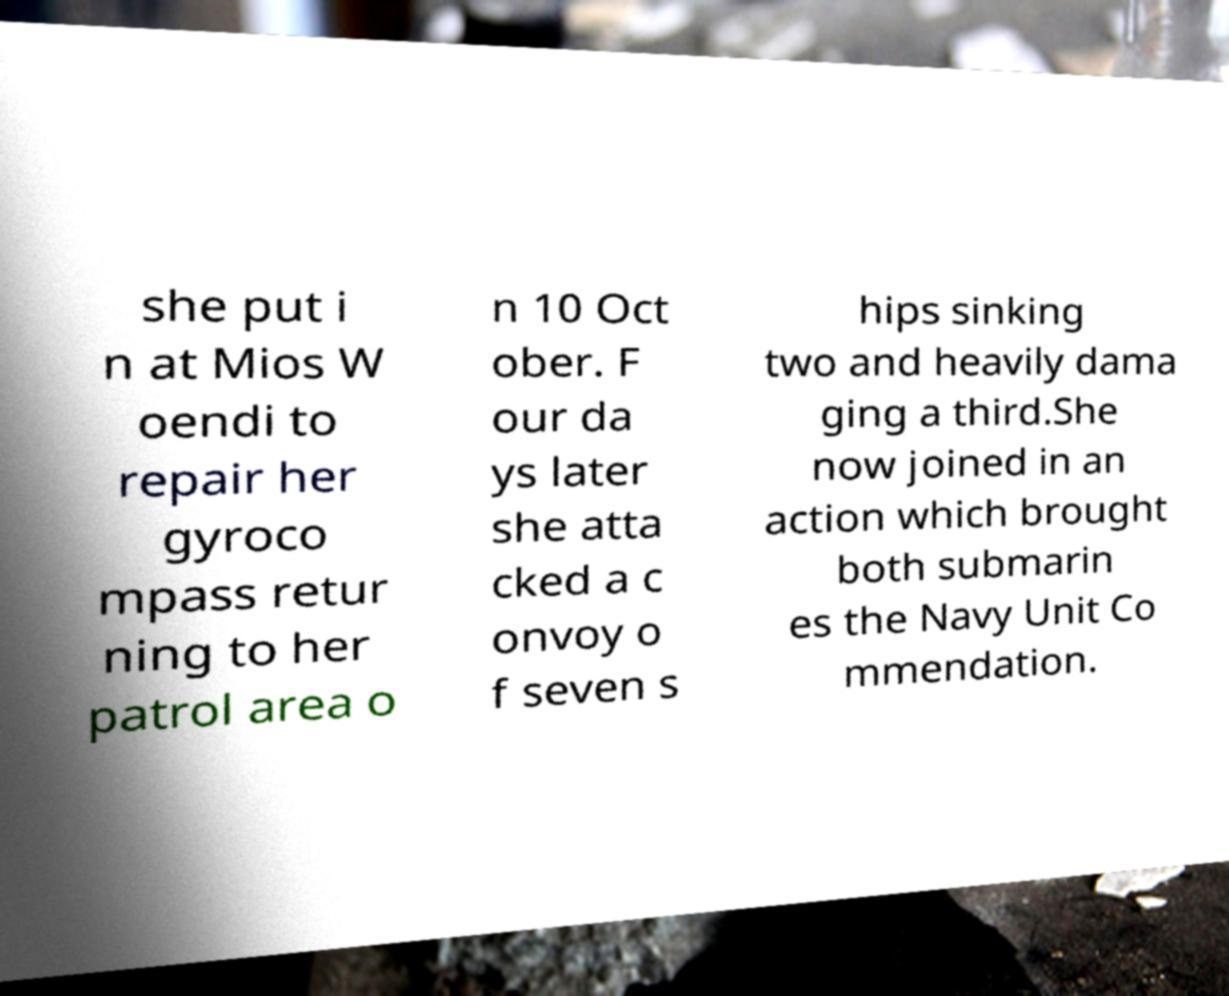Can you read and provide the text displayed in the image?This photo seems to have some interesting text. Can you extract and type it out for me? she put i n at Mios W oendi to repair her gyroco mpass retur ning to her patrol area o n 10 Oct ober. F our da ys later she atta cked a c onvoy o f seven s hips sinking two and heavily dama ging a third.She now joined in an action which brought both submarin es the Navy Unit Co mmendation. 